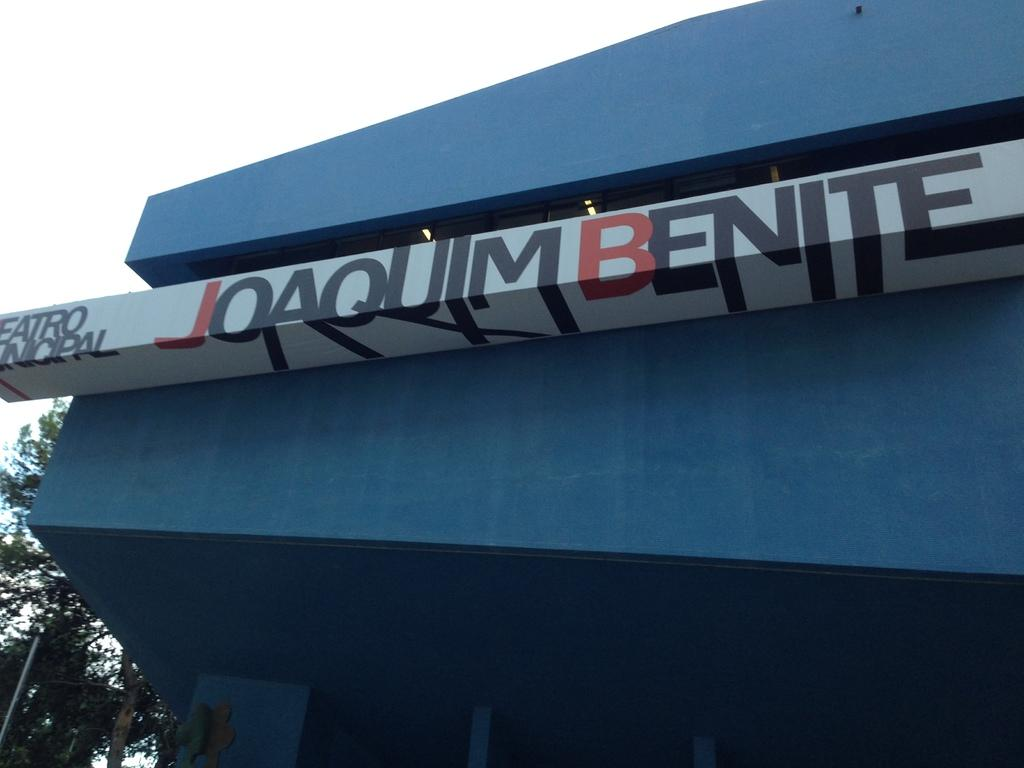What is attached to the building in the image? There is a hoarding attached to the building in the image. What is the color of the building? The building is blue in color. What can be seen in the background of the image? There are trees and the sky visible in the background of the image. How many goldfish are swimming in the building's fountain in the image? There is no fountain or goldfish present in the image. Are the building's brothers arguing about the hoarding's design in the image? There is no mention of brothers or any argument in the image. 